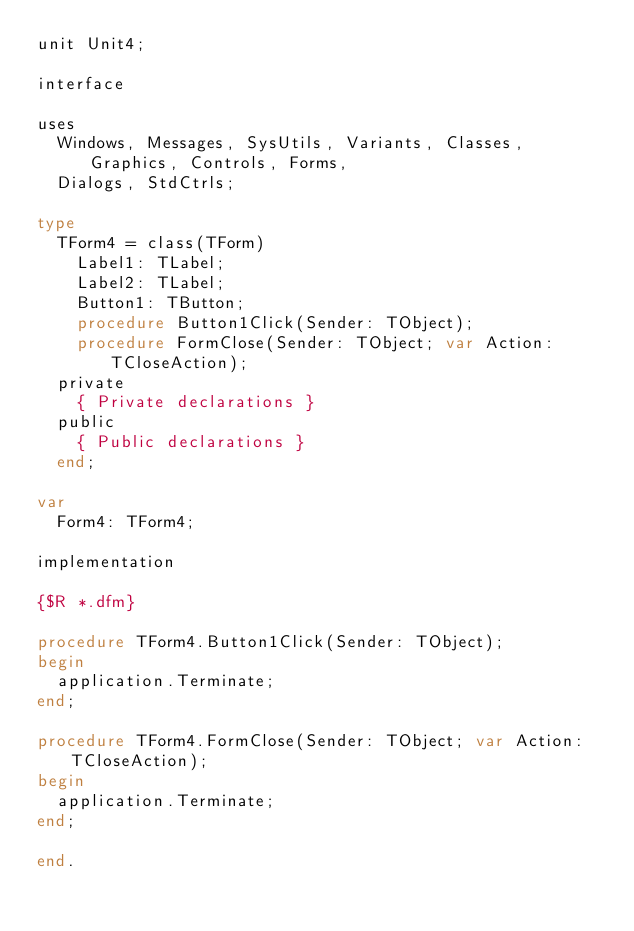Convert code to text. <code><loc_0><loc_0><loc_500><loc_500><_Pascal_>unit Unit4;

interface

uses
  Windows, Messages, SysUtils, Variants, Classes, Graphics, Controls, Forms,
  Dialogs, StdCtrls;

type
  TForm4 = class(TForm)
    Label1: TLabel;
    Label2: TLabel;
    Button1: TButton;
    procedure Button1Click(Sender: TObject);
    procedure FormClose(Sender: TObject; var Action: TCloseAction);
  private
    { Private declarations }
  public
    { Public declarations }
  end;

var
  Form4: TForm4;

implementation

{$R *.dfm}

procedure TForm4.Button1Click(Sender: TObject);
begin
  application.Terminate;
end;

procedure TForm4.FormClose(Sender: TObject; var Action: TCloseAction);
begin
  application.Terminate;
end;

end.
</code> 